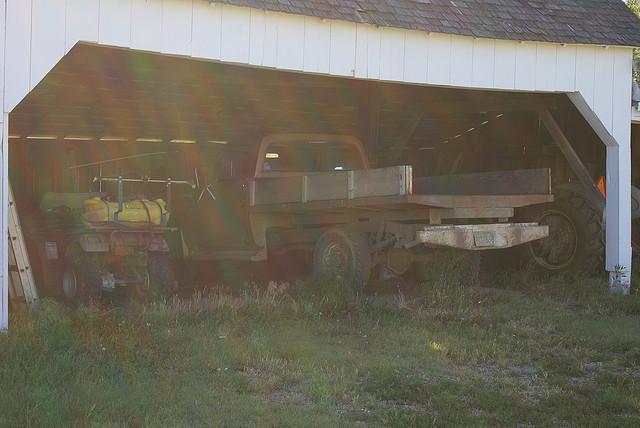How many trucks are in the photo?
Give a very brief answer. 2. How many people are walking under the red umbrella?
Give a very brief answer. 0. 